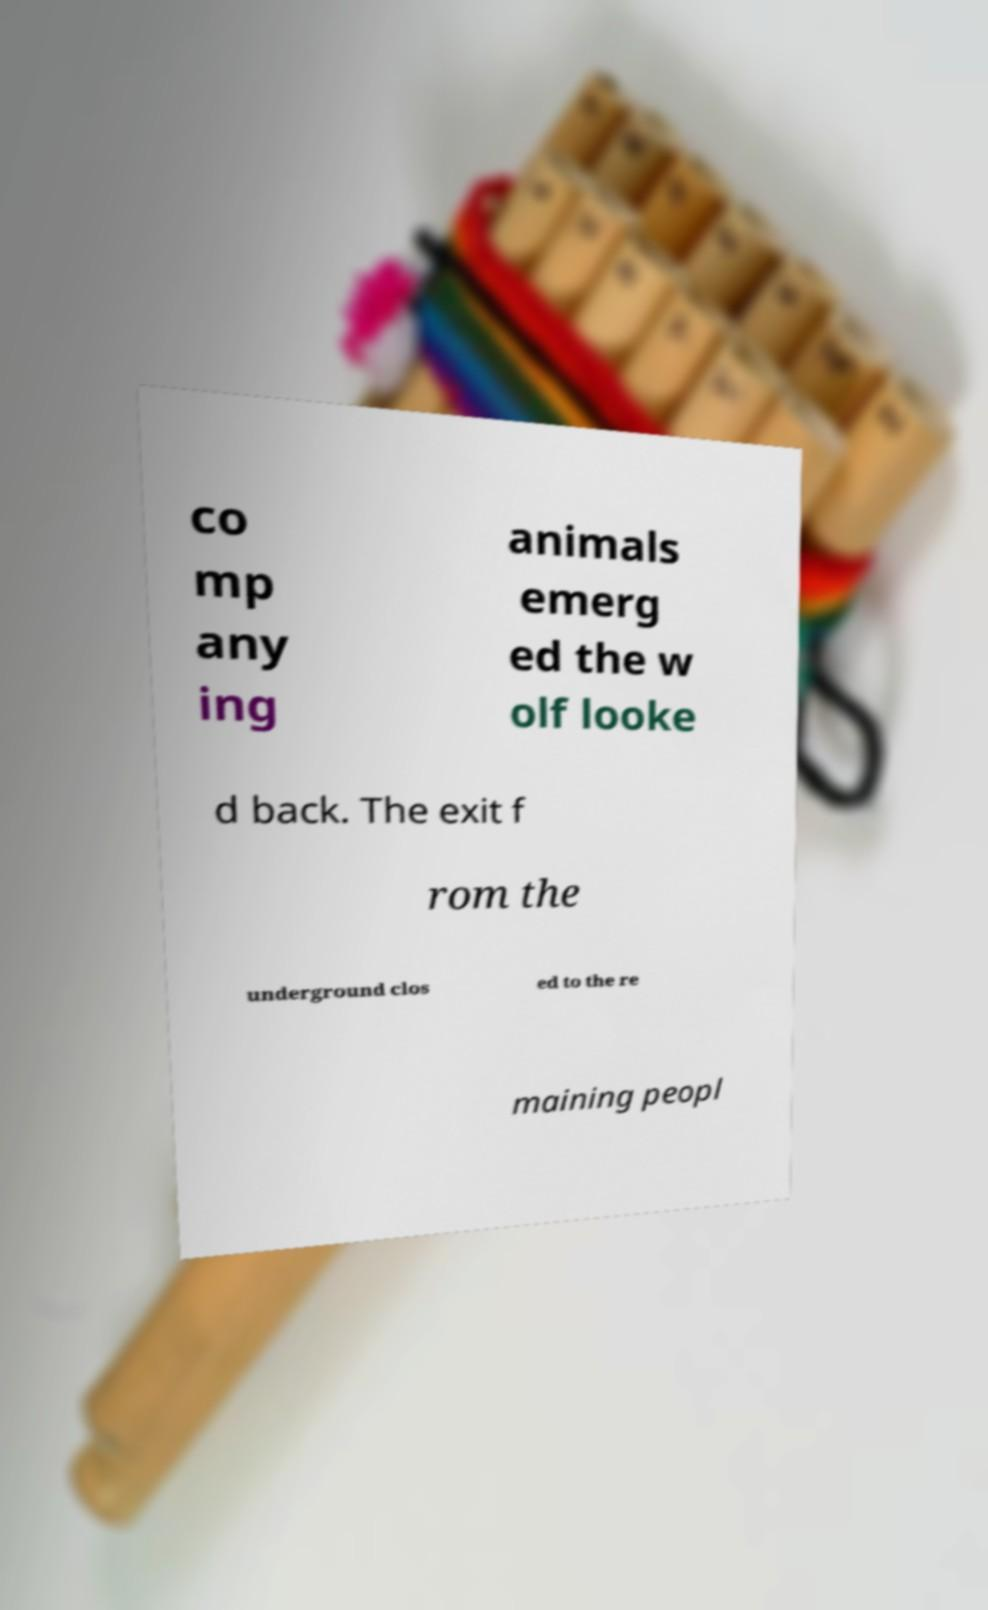Please identify and transcribe the text found in this image. co mp any ing animals emerg ed the w olf looke d back. The exit f rom the underground clos ed to the re maining peopl 